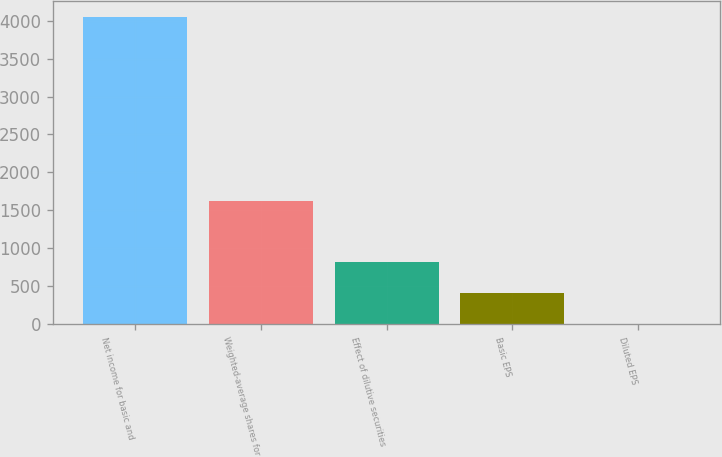Convert chart to OTSL. <chart><loc_0><loc_0><loc_500><loc_500><bar_chart><fcel>Net income for basic and<fcel>Weighted-average shares for<fcel>Effect of dilutive securities<fcel>Basic EPS<fcel>Diluted EPS<nl><fcel>4052<fcel>1623.05<fcel>813.41<fcel>408.59<fcel>3.77<nl></chart> 